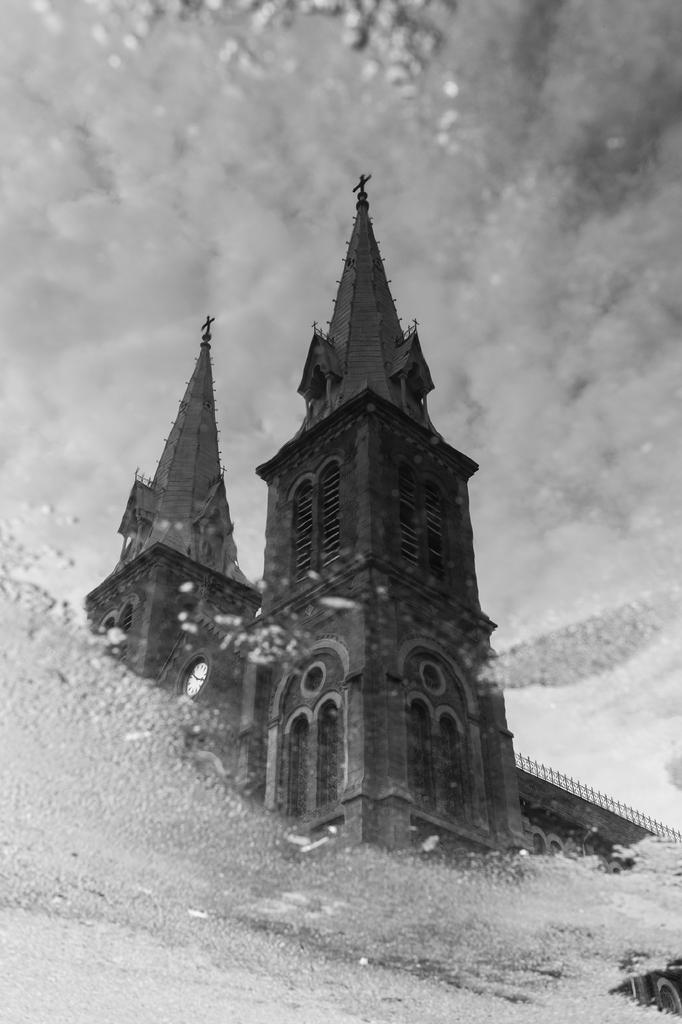What type of structure is present in the image? There is a building in the image. What can be seen in the sky in the image? There are clouds visible at the top of the image. What is the condition of the mirror in the foreground of the image? There is fog on the mirror in the foreground of the image. What type of fruit is being served for breakfast in the image? There is no fruit or breakfast depicted in the image. 